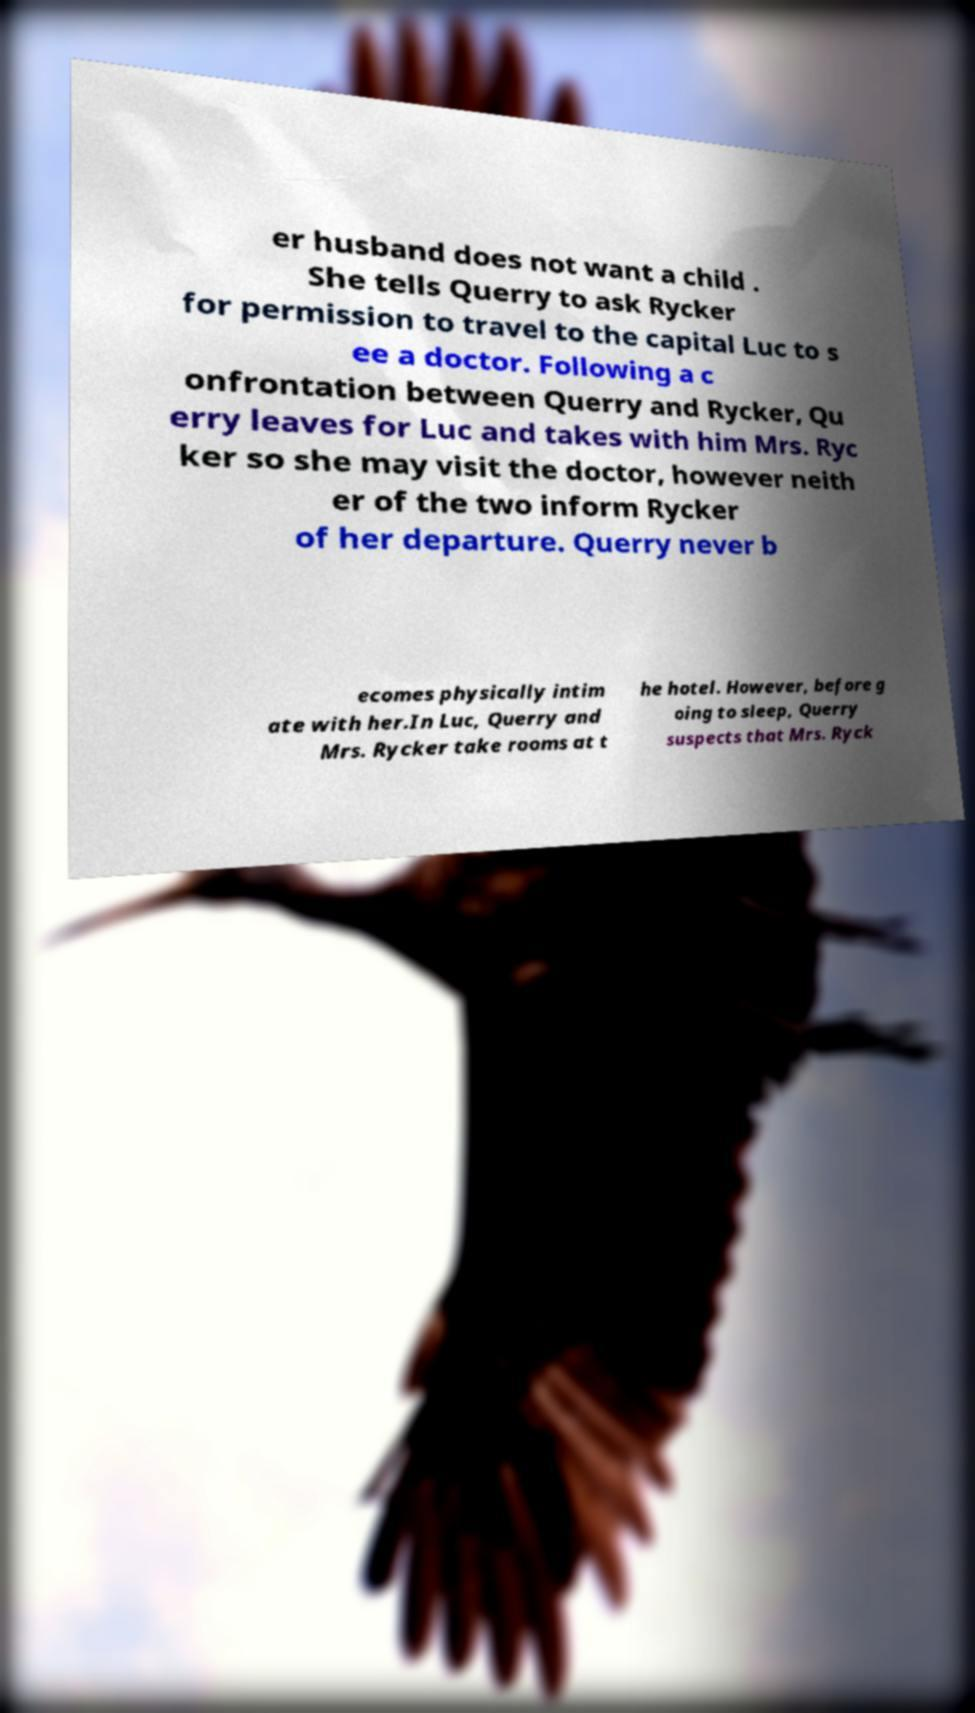There's text embedded in this image that I need extracted. Can you transcribe it verbatim? er husband does not want a child . She tells Querry to ask Rycker for permission to travel to the capital Luc to s ee a doctor. Following a c onfrontation between Querry and Rycker, Qu erry leaves for Luc and takes with him Mrs. Ryc ker so she may visit the doctor, however neith er of the two inform Rycker of her departure. Querry never b ecomes physically intim ate with her.In Luc, Querry and Mrs. Rycker take rooms at t he hotel. However, before g oing to sleep, Querry suspects that Mrs. Ryck 